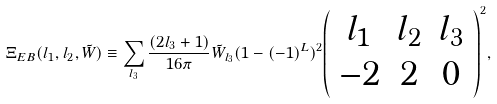<formula> <loc_0><loc_0><loc_500><loc_500>\Xi _ { E B } ( l _ { 1 } , l _ { 2 } , \tilde { W } ) \equiv \sum _ { l _ { 3 } } \frac { ( 2 l _ { 3 } + 1 ) } { 1 6 \pi } \tilde { W } _ { l _ { 3 } } ( 1 - ( - 1 ) ^ { L } ) ^ { 2 } { \left ( \begin{array} { c c c } l _ { 1 } & l _ { 2 } & l _ { 3 } \\ - 2 & 2 & 0 \end{array} \right ) ^ { 2 } } ,</formula> 